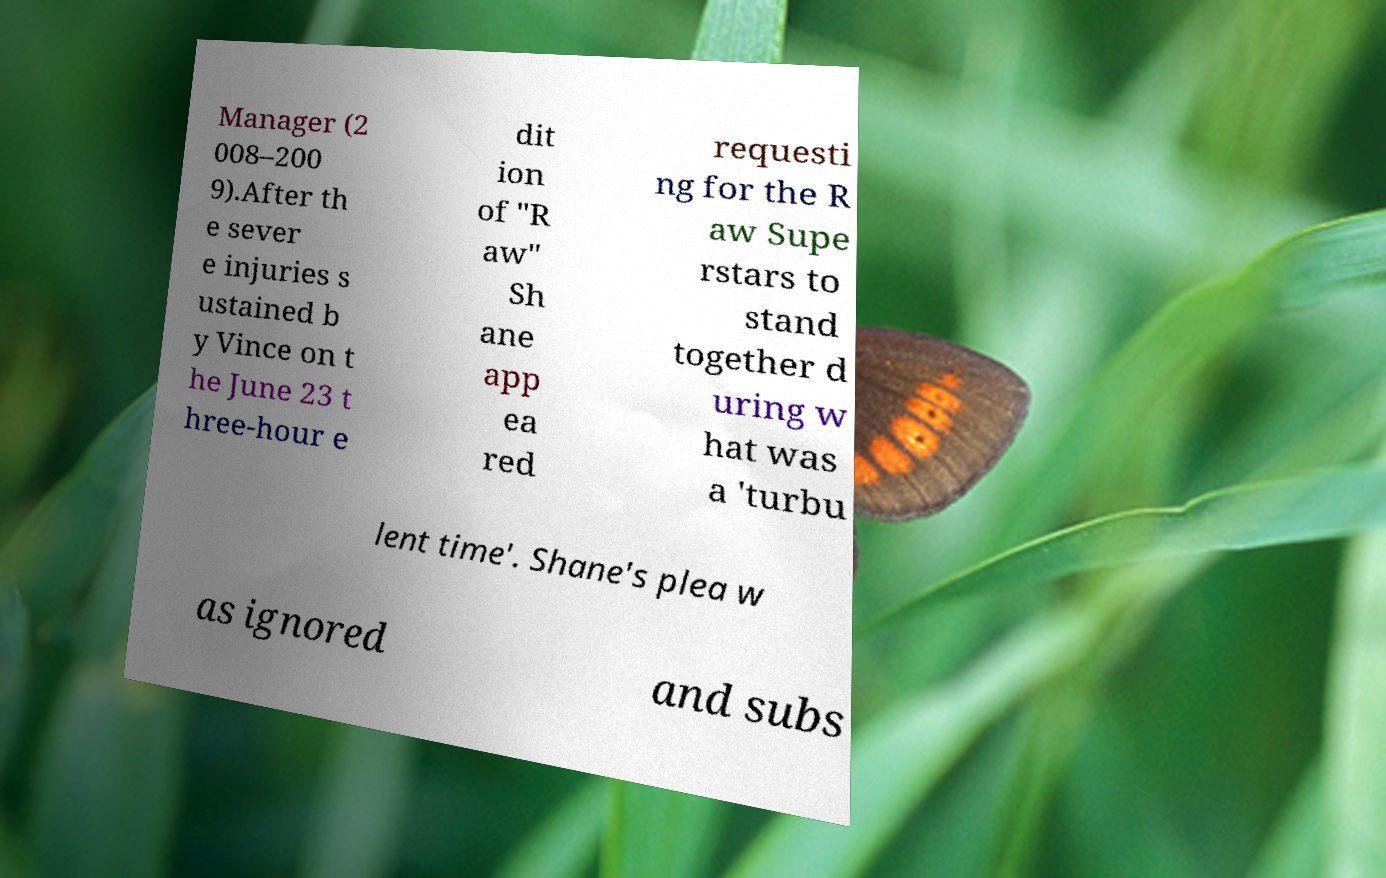What messages or text are displayed in this image? I need them in a readable, typed format. Manager (2 008–200 9).After th e sever e injuries s ustained b y Vince on t he June 23 t hree-hour e dit ion of "R aw" Sh ane app ea red requesti ng for the R aw Supe rstars to stand together d uring w hat was a 'turbu lent time'. Shane's plea w as ignored and subs 